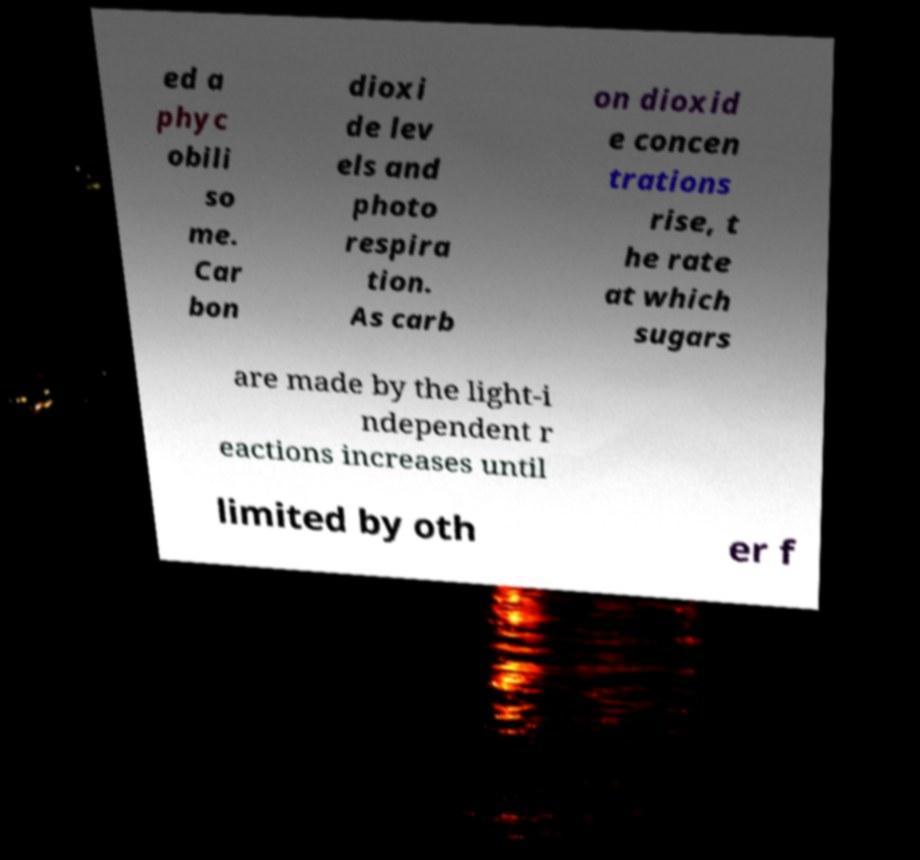There's text embedded in this image that I need extracted. Can you transcribe it verbatim? ed a phyc obili so me. Car bon dioxi de lev els and photo respira tion. As carb on dioxid e concen trations rise, t he rate at which sugars are made by the light-i ndependent r eactions increases until limited by oth er f 